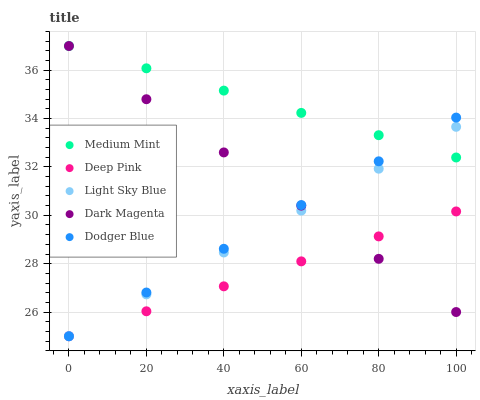Does Deep Pink have the minimum area under the curve?
Answer yes or no. Yes. Does Medium Mint have the maximum area under the curve?
Answer yes or no. Yes. Does Dodger Blue have the minimum area under the curve?
Answer yes or no. No. Does Dodger Blue have the maximum area under the curve?
Answer yes or no. No. Is Deep Pink the smoothest?
Answer yes or no. Yes. Is Medium Mint the roughest?
Answer yes or no. Yes. Is Dodger Blue the smoothest?
Answer yes or no. No. Is Dodger Blue the roughest?
Answer yes or no. No. Does Deep Pink have the lowest value?
Answer yes or no. Yes. Does Dark Magenta have the lowest value?
Answer yes or no. No. Does Dark Magenta have the highest value?
Answer yes or no. Yes. Does Dodger Blue have the highest value?
Answer yes or no. No. Is Deep Pink less than Medium Mint?
Answer yes or no. Yes. Is Medium Mint greater than Deep Pink?
Answer yes or no. Yes. Does Dodger Blue intersect Light Sky Blue?
Answer yes or no. Yes. Is Dodger Blue less than Light Sky Blue?
Answer yes or no. No. Is Dodger Blue greater than Light Sky Blue?
Answer yes or no. No. Does Deep Pink intersect Medium Mint?
Answer yes or no. No. 